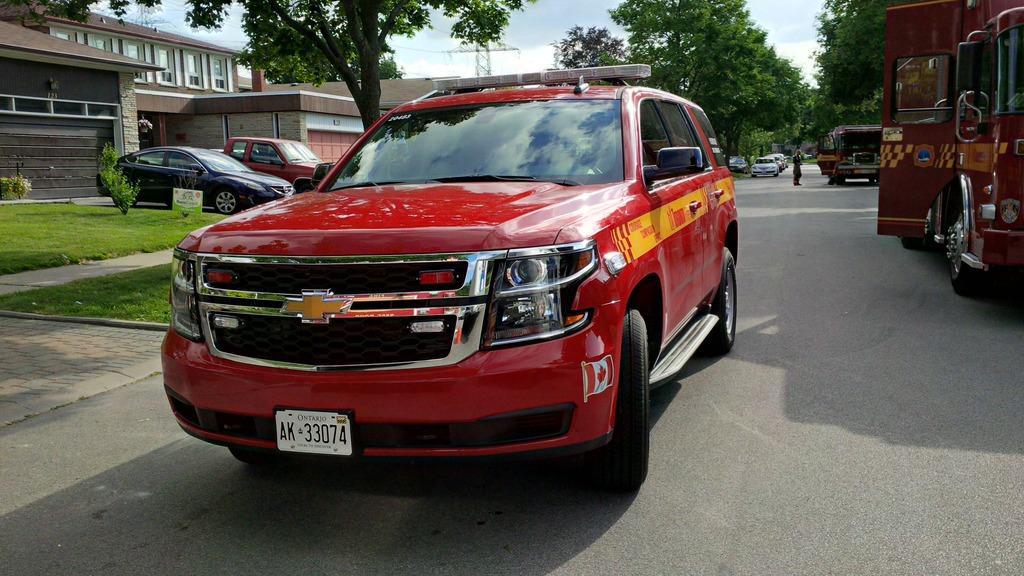Please provide a concise description of this image. In front of the image there is a car, behind the car on the road there are cars, trucks and a person, in the background of the image there are trees, houses, electric poles with cables on it, plants and grass on the surface. 